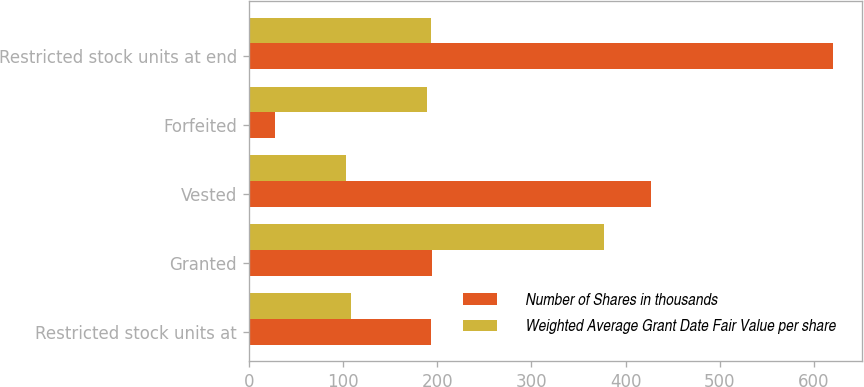Convert chart. <chart><loc_0><loc_0><loc_500><loc_500><stacked_bar_chart><ecel><fcel>Restricted stock units at<fcel>Granted<fcel>Vested<fcel>Forfeited<fcel>Restricted stock units at end<nl><fcel>Number of Shares in thousands<fcel>193.53<fcel>195<fcel>427<fcel>28<fcel>620<nl><fcel>Weighted Average Grant Date Fair Value per share<fcel>109.01<fcel>376.95<fcel>103.54<fcel>189.05<fcel>193.53<nl></chart> 